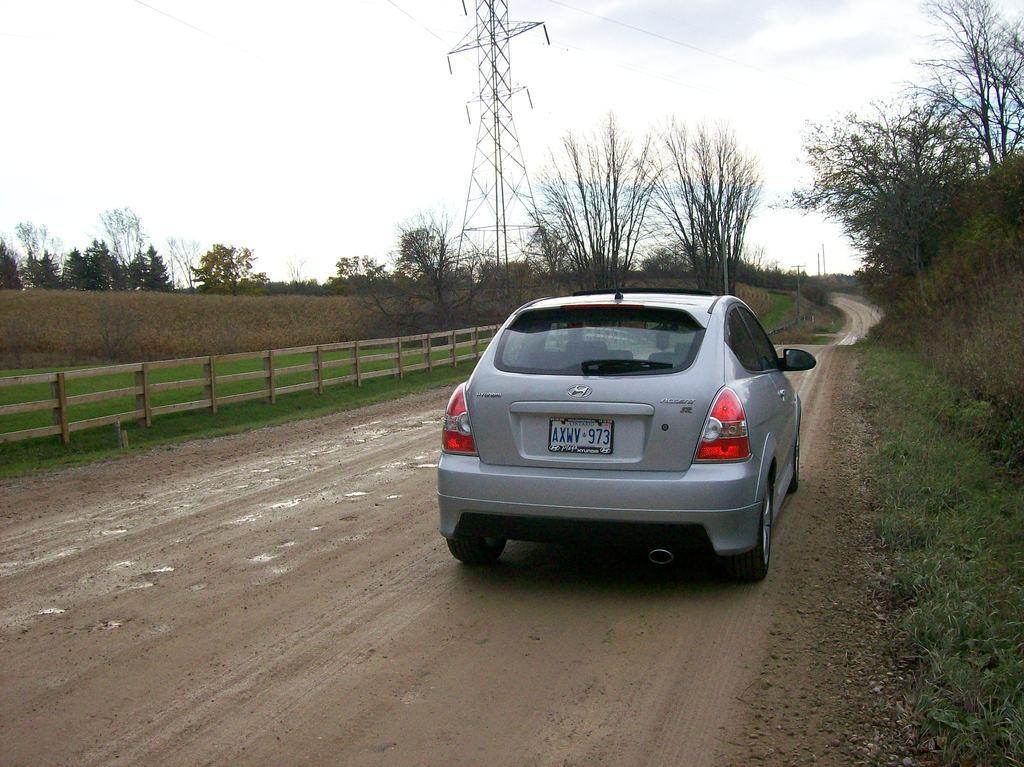Please provide a concise description of this image. In this image we can see one antenna with some wires, some poles, so many big trees, plants, bushes and grass on the ground. There is one fence near to the road, one car on the road and at the top there is the sky. 